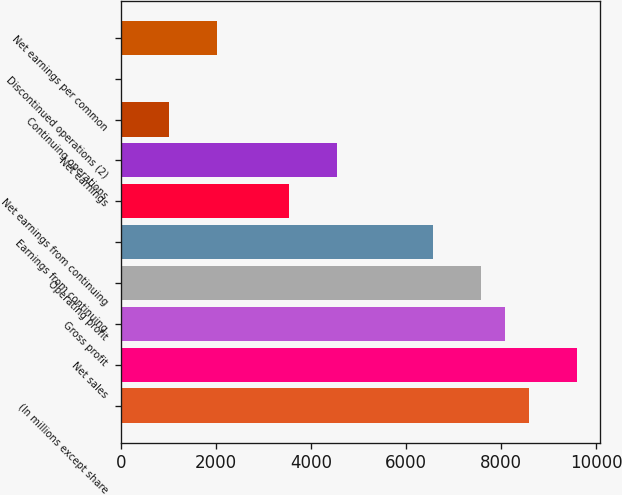<chart> <loc_0><loc_0><loc_500><loc_500><bar_chart><fcel>(In millions except share<fcel>Net sales<fcel>Gross profit<fcel>Operating profit<fcel>Earnings from continuing<fcel>Net earnings from continuing<fcel>Net earnings<fcel>Continuing operations<fcel>Discontinued operations (2)<fcel>Net earnings per common<nl><fcel>8585.1<fcel>9595.08<fcel>8080.11<fcel>7575.12<fcel>6565.14<fcel>3535.2<fcel>4545.18<fcel>1010.25<fcel>0.27<fcel>2020.23<nl></chart> 